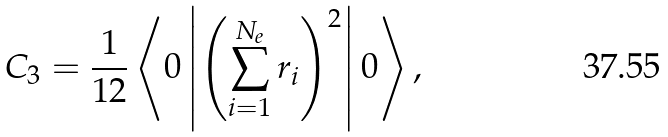<formula> <loc_0><loc_0><loc_500><loc_500>C _ { 3 } = \frac { 1 } { 1 2 } \left \langle 0 \left | \left ( \sum _ { i = 1 } ^ { N _ { e } } r _ { i } \right ) ^ { 2 } \right | 0 \right \rangle ,</formula> 